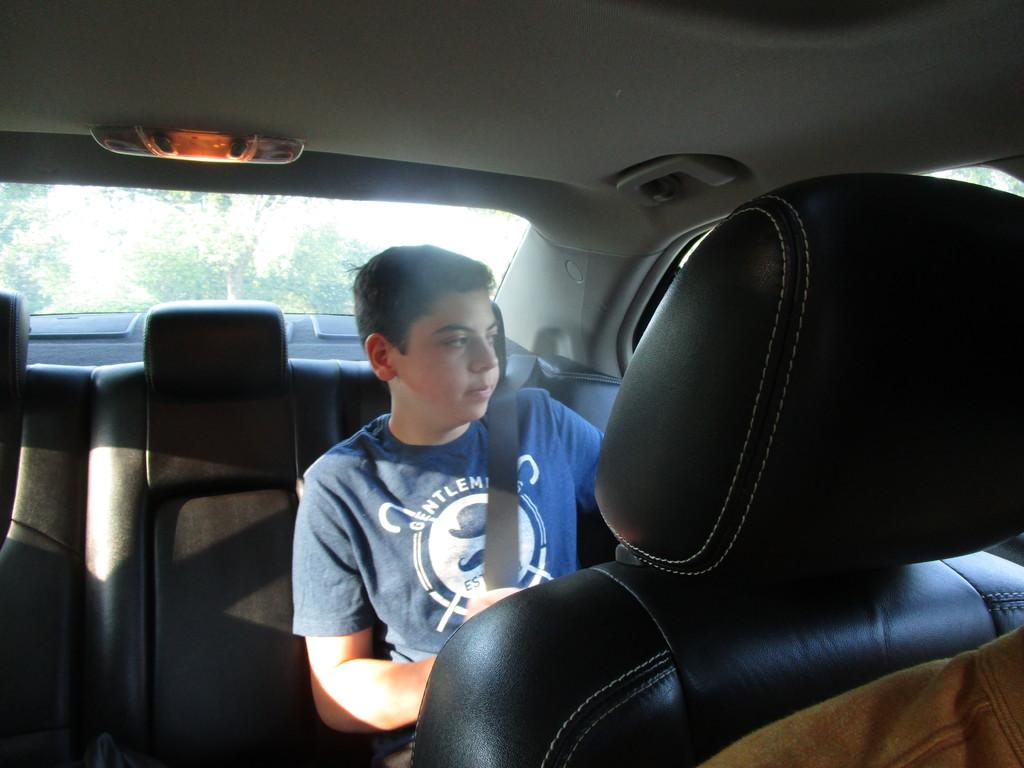What type of vehicle is shown in the image? The image shows an inner view of a car. Who is present in the car? There is a man seated in the back of the car. Is the man taking any safety precautions? Yes, the man is wearing a seat belt. What type of drug is the man holding in the image? There is no drug present in the image; the man is wearing a seat belt and there is no indication of any drug. 